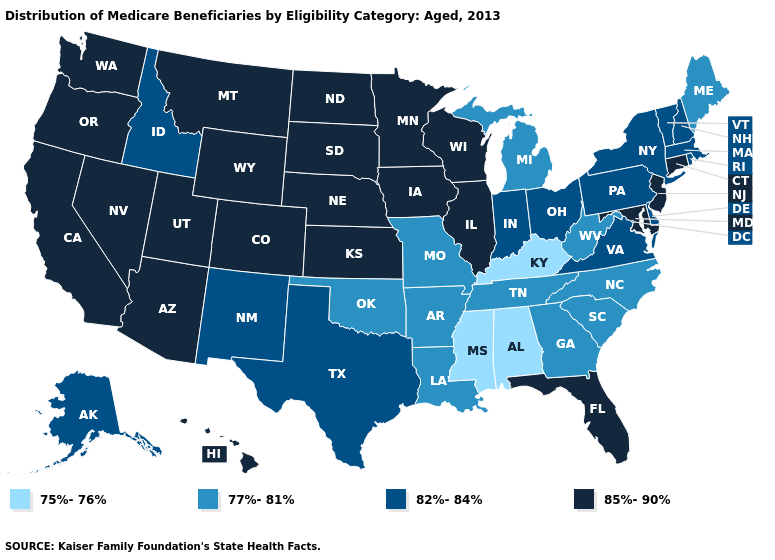Name the states that have a value in the range 85%-90%?
Short answer required. Arizona, California, Colorado, Connecticut, Florida, Hawaii, Illinois, Iowa, Kansas, Maryland, Minnesota, Montana, Nebraska, Nevada, New Jersey, North Dakota, Oregon, South Dakota, Utah, Washington, Wisconsin, Wyoming. What is the value of New Hampshire?
Give a very brief answer. 82%-84%. What is the value of Virginia?
Be succinct. 82%-84%. What is the value of Kansas?
Give a very brief answer. 85%-90%. Does Ohio have the lowest value in the MidWest?
Give a very brief answer. No. Name the states that have a value in the range 77%-81%?
Concise answer only. Arkansas, Georgia, Louisiana, Maine, Michigan, Missouri, North Carolina, Oklahoma, South Carolina, Tennessee, West Virginia. Is the legend a continuous bar?
Keep it brief. No. Does Idaho have a higher value than West Virginia?
Keep it brief. Yes. Does the map have missing data?
Be succinct. No. What is the lowest value in the USA?
Write a very short answer. 75%-76%. What is the lowest value in the USA?
Keep it brief. 75%-76%. Which states have the lowest value in the West?
Answer briefly. Alaska, Idaho, New Mexico. Does the map have missing data?
Give a very brief answer. No. Name the states that have a value in the range 82%-84%?
Short answer required. Alaska, Delaware, Idaho, Indiana, Massachusetts, New Hampshire, New Mexico, New York, Ohio, Pennsylvania, Rhode Island, Texas, Vermont, Virginia. Is the legend a continuous bar?
Short answer required. No. 